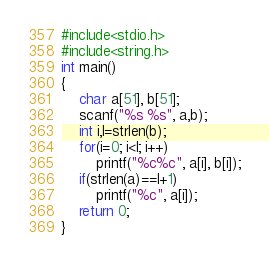Convert code to text. <code><loc_0><loc_0><loc_500><loc_500><_C++_>#include<stdio.h>
#include<string.h>
int main()
{
	char a[51], b[51];
	scanf("%s %s", a,b);
	int i,l=strlen(b);
	for(i=0; i<l; i++)
		printf("%c%c", a[i], b[i]);
	if(strlen(a)==l+1)
		printf("%c", a[i]);
	return 0;
}</code> 